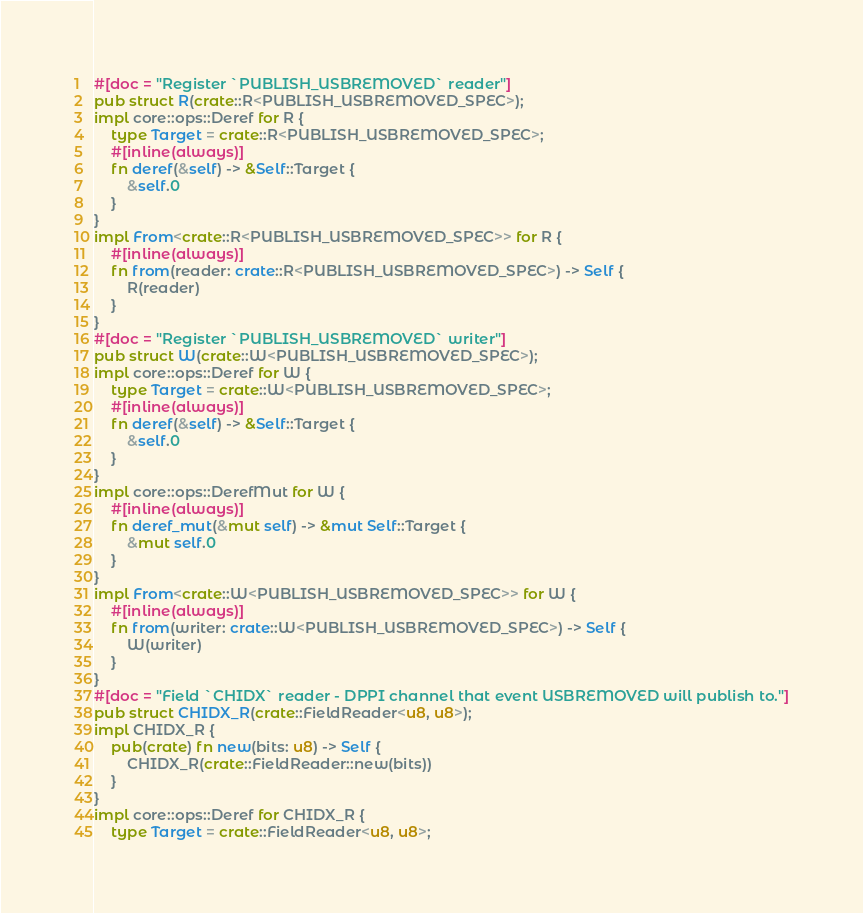<code> <loc_0><loc_0><loc_500><loc_500><_Rust_>#[doc = "Register `PUBLISH_USBREMOVED` reader"]
pub struct R(crate::R<PUBLISH_USBREMOVED_SPEC>);
impl core::ops::Deref for R {
    type Target = crate::R<PUBLISH_USBREMOVED_SPEC>;
    #[inline(always)]
    fn deref(&self) -> &Self::Target {
        &self.0
    }
}
impl From<crate::R<PUBLISH_USBREMOVED_SPEC>> for R {
    #[inline(always)]
    fn from(reader: crate::R<PUBLISH_USBREMOVED_SPEC>) -> Self {
        R(reader)
    }
}
#[doc = "Register `PUBLISH_USBREMOVED` writer"]
pub struct W(crate::W<PUBLISH_USBREMOVED_SPEC>);
impl core::ops::Deref for W {
    type Target = crate::W<PUBLISH_USBREMOVED_SPEC>;
    #[inline(always)]
    fn deref(&self) -> &Self::Target {
        &self.0
    }
}
impl core::ops::DerefMut for W {
    #[inline(always)]
    fn deref_mut(&mut self) -> &mut Self::Target {
        &mut self.0
    }
}
impl From<crate::W<PUBLISH_USBREMOVED_SPEC>> for W {
    #[inline(always)]
    fn from(writer: crate::W<PUBLISH_USBREMOVED_SPEC>) -> Self {
        W(writer)
    }
}
#[doc = "Field `CHIDX` reader - DPPI channel that event USBREMOVED will publish to."]
pub struct CHIDX_R(crate::FieldReader<u8, u8>);
impl CHIDX_R {
    pub(crate) fn new(bits: u8) -> Self {
        CHIDX_R(crate::FieldReader::new(bits))
    }
}
impl core::ops::Deref for CHIDX_R {
    type Target = crate::FieldReader<u8, u8>;</code> 